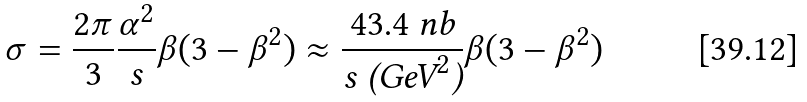Convert formula to latex. <formula><loc_0><loc_0><loc_500><loc_500>\sigma = \frac { 2 \pi } { 3 } \frac { \alpha ^ { 2 } } { s } \beta ( 3 - \beta ^ { 2 } ) \approx \frac { 4 3 . 4 \text { nb} } { s \text { (GeV} ^ { 2 } \text {)} } \beta ( 3 - \beta ^ { 2 } )</formula> 